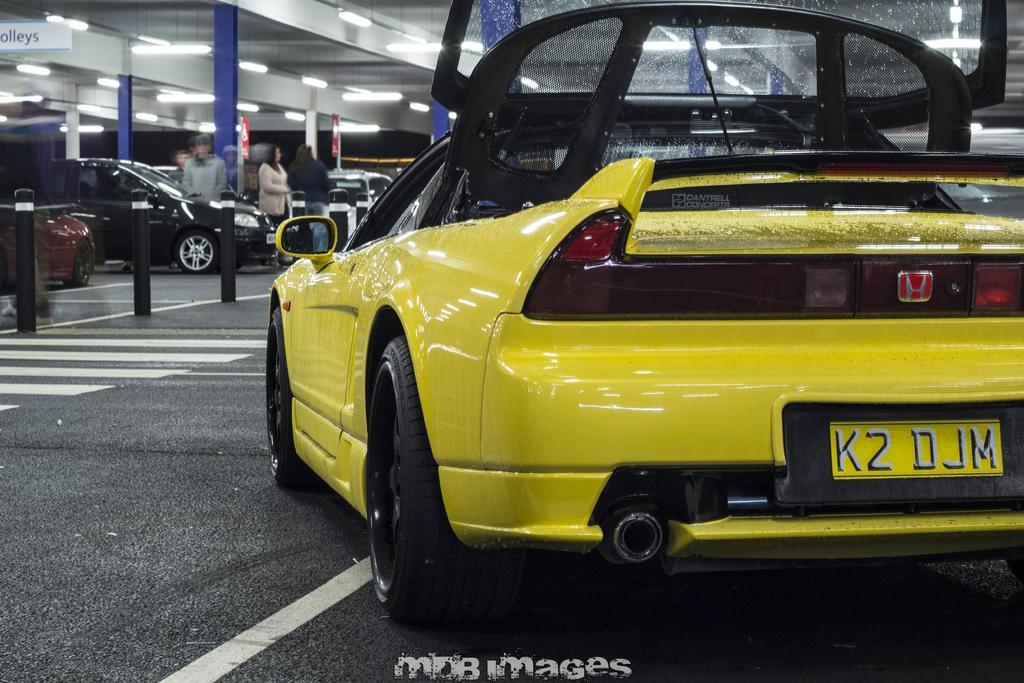Can you describe this image briefly? In this picture we can see few cars and group of people, and also we can see few metal rods and lights, at the middle bottom of the image we can see a watermark. 